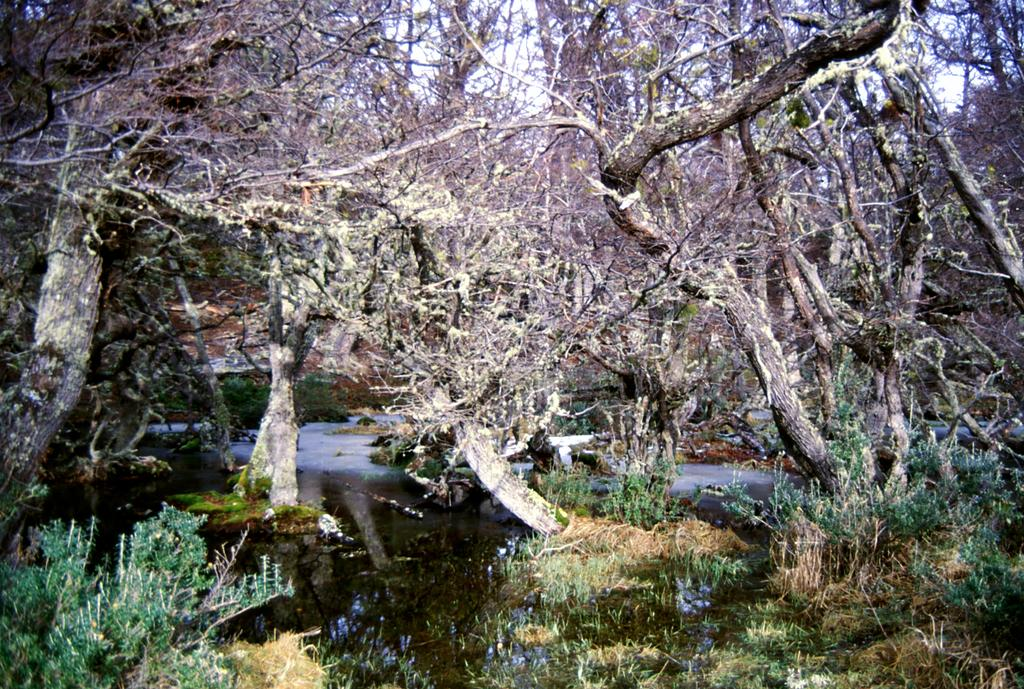What is present at the bottom of the image? There is water at the bottom of the image. What can be seen in the background of the image? There are trees in the background of the image. Where is the plant located in the image? The plant is on the left side of the image. What is visible at the top of the image? The sky is visible at the top of the image. How many potatoes can be seen growing in the patch in the image? There is no potato patch present in the image, and therefore no potatoes can be seen growing. What type of lettuce is visible in the image? There is no lettuce present in the image. 